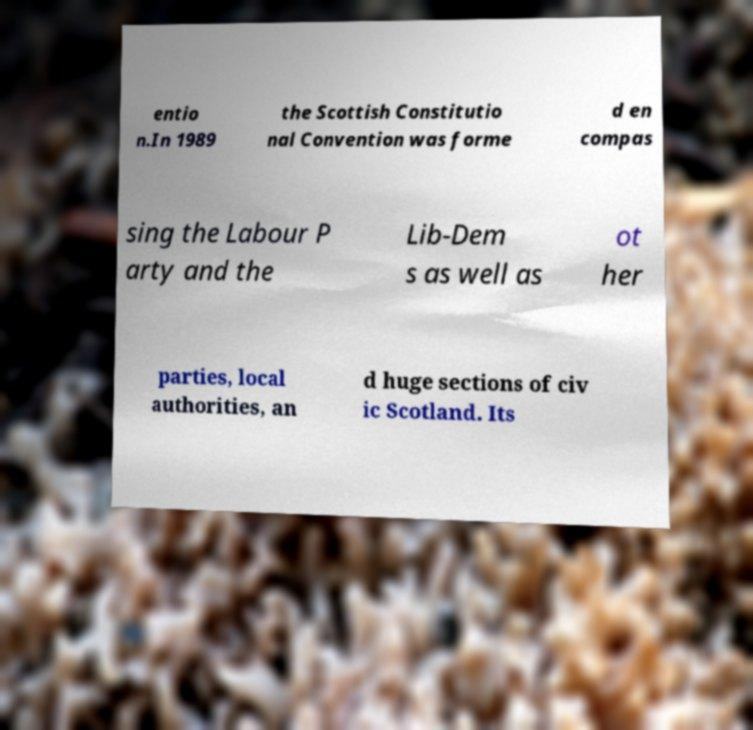For documentation purposes, I need the text within this image transcribed. Could you provide that? entio n.In 1989 the Scottish Constitutio nal Convention was forme d en compas sing the Labour P arty and the Lib-Dem s as well as ot her parties, local authorities, an d huge sections of civ ic Scotland. Its 